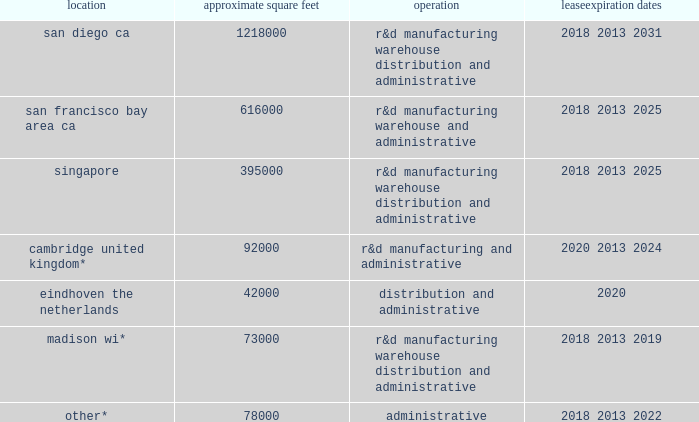Table of contents item 2 .
Properties .
The table summarizes the facilities we lease as of december 31 , 2017 , including the location and size of each principal facility , and their designated use .
We believe our facilities are adequate for our current and near-term needs , and will be able to locate additional facilities as needed .
Location approximate square feet operation expiration dates .
________________ *excludes approximately 309000 square feet for which the leases do not commence until 2018 and beyond .
Item 3 .
Legal proceedings .
We are involved in various lawsuits and claims arising in the ordinary course of business , including actions with respect to intellectual property , employment , and contractual matters .
In connection with these matters , we assess , on a regular basis , the probability and range of possible loss based on the developments in these matters .
A liability is recorded in the financial statements if it is believed to be probable that a loss has been incurred and the amount of the loss can be reasonably estimated .
Because litigation is inherently unpredictable and unfavorable results could occur , assessing contingencies is highly subjective and requires judgments about future events .
We regularly review outstanding legal matters to determine the adequacy of the liabilities accrued and related disclosures .
The amount of ultimate loss may differ from these estimates .
Each matter presents its own unique circumstances , and prior litigation does not necessarily provide a reliable basis on which to predict the outcome , or range of outcomes , in any individual proceeding .
Because of the uncertainties related to the occurrence , amount , and range of loss on any pending litigation or claim , we are currently unable to predict their ultimate outcome , and , with respect to any pending litigation or claim where no liability has been accrued , to make a meaningful estimate of the reasonably possible loss or range of loss that could result from an unfavorable outcome .
In the event opposing litigants in outstanding litigations or claims ultimately succeed at trial and any subsequent appeals on their claims , any potential loss or charges in excess of any established accruals , individually or in the aggregate , could have a material adverse effect on our business , financial condition , results of operations , and/or cash flows in the period in which the unfavorable outcome occurs or becomes probable , and potentially in future periods .
Item 4 .
Mine safety disclosures .
Not applicable. .
In madison wi what was the ratio of the square feet excluded for which the leases do not commence until 2018 as of december 31 , 2017? 
Rationale: in madison wi there was 4.23 square feet excluded for which the leases do not commence until 2018 as of december 31 , 2017 per foot reported
Computations: (309000 / 73000)
Answer: 4.23288. 